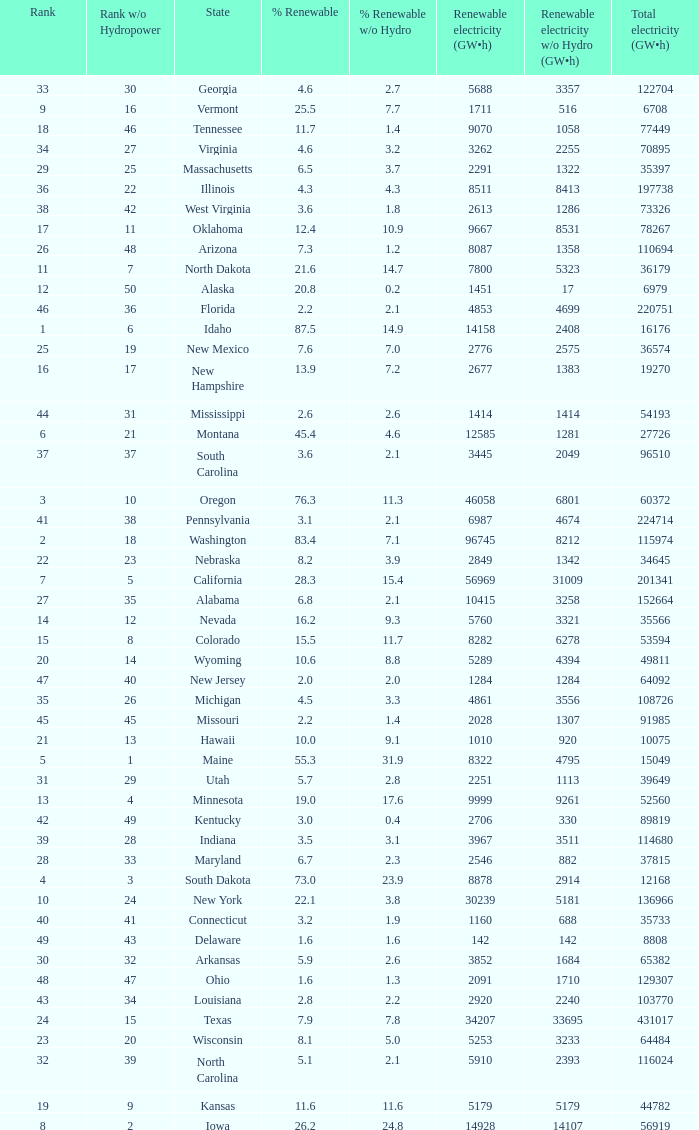What is the amount of renewable electricity without hydrogen power when the percentage of renewable energy is 83.4? 8212.0. 